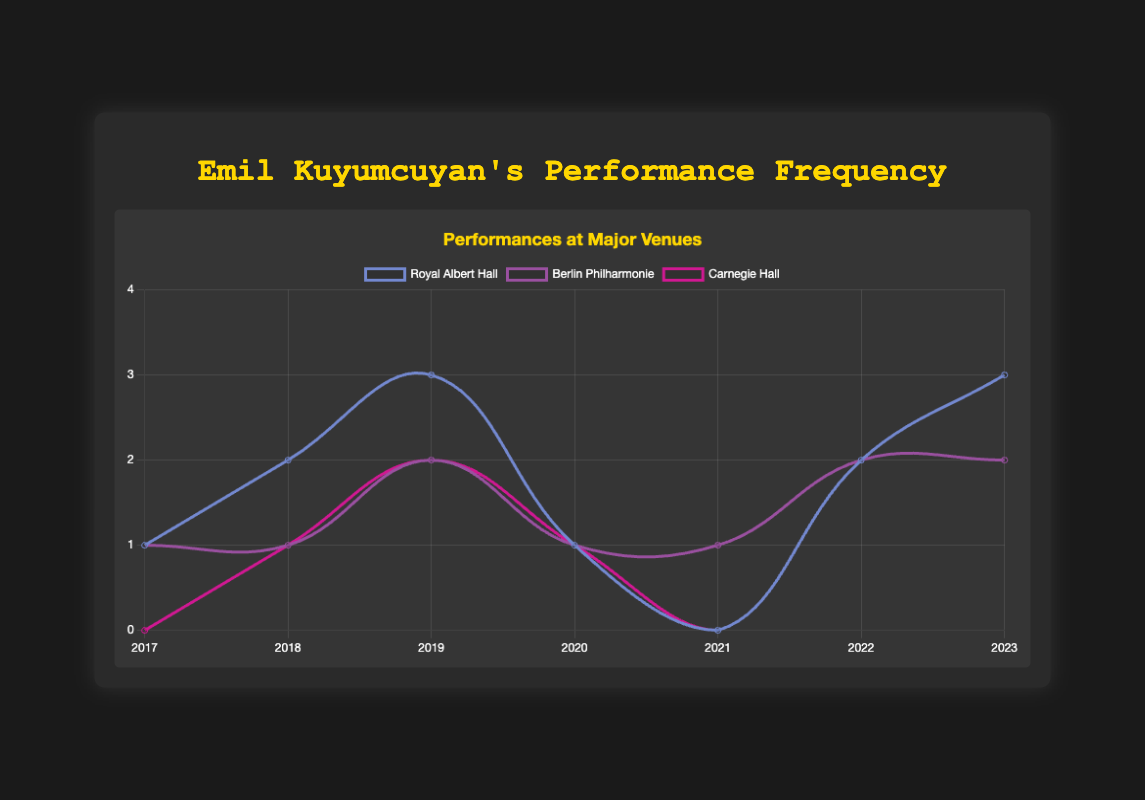Which venue had the highest number of performances in 2019? To find the venue with the highest performances in 2019, look at the 2019 data points and compare the performance values for each venue. In 2019, Royal Albert Hall had 3, Berlin Philharmonie had 2, and Carnegie Hall had 2. Therefore, Royal Albert Hall had the highest number of performances with 3.
Answer: Royal Albert Hall How did Emil Kuyumcuyan's total performances at Royal Albert Hall change from 2017 to 2023? To find the change, compare the number of performances at Royal Albert Hall in 2017 and 2023. In 2017, there was 1 performance, and in 2023, there were 3 performances. The change is 3 - 1 = 2.
Answer: Increased by 2 What was the overall trend in performances at Carnegie Hall from 2018 to 2023? To observe the trend, track the number of performances over the years at Carnegie Hall from 2018 to 2023. In 2018, there was 1 performance, in 2019, there were 2, in 2020, there was 1, in 2021, there were 0, in 2022, there were 2, and in 2023, there were 3 performances. The overall trend shows an increase with some fluctuations.
Answer: Increasing trend In which year did Emil Kuyumcuyan perform at the Berlin Philharmonie the most? To find this, locate the year with the highest number of performances at Berlin Philharmonie. The data shows that in both 2022 and 2023, there were 2 performances each, the highest number across the years.
Answer: 2022 and 2023 Which venue had no performances in 2021? To determine this, check the performance values for each venue in 2021. The data shows that Royal Albert Hall and Carnegie Hall had 0 performances in 2021, whereas Berlin Philharmonie had 1.
Answer: Royal Albert Hall and Carnegie Hall Compare the performances at Royal Albert Hall and Carnegie Hall in 2020. Which was higher? To compare, look at the performance numbers for Royal Albert Hall and Carnegie Hall in 2020. Both venues had 1 performance each in 2020.
Answer: Equal How many total performances did Emil Kuyumcuyan have across all venues in 2018? Sum the number of performances in 2018 for Royal Albert Hall (2), Berlin Philharmonie (1), and Carnegie Hall (1). The total is 2 + 1 + 1 = 4.
Answer: 4 Which venue had the most consistent number of performances from 2017 to 2023, and what was the range of its performances? To determine consistency, check the performance numbers for each venue over the years. Berlin Philharmonie's performances ranged from 1 to 2 with no 0s, more consistent compared to the other venues. The range is 2 - 1 = 1.
Answer: Berlin Philharmonie, range 1 Describe the trend in performances at Royal Albert Hall from 2017 to 2019. To describe the trend, observe the number of performances each year. In 2017, there was 1 performance, in 2018, there were 2, and in 2019, there were 3. This indicates a consistent year-over-year increase.
Answer: Increasing trend 